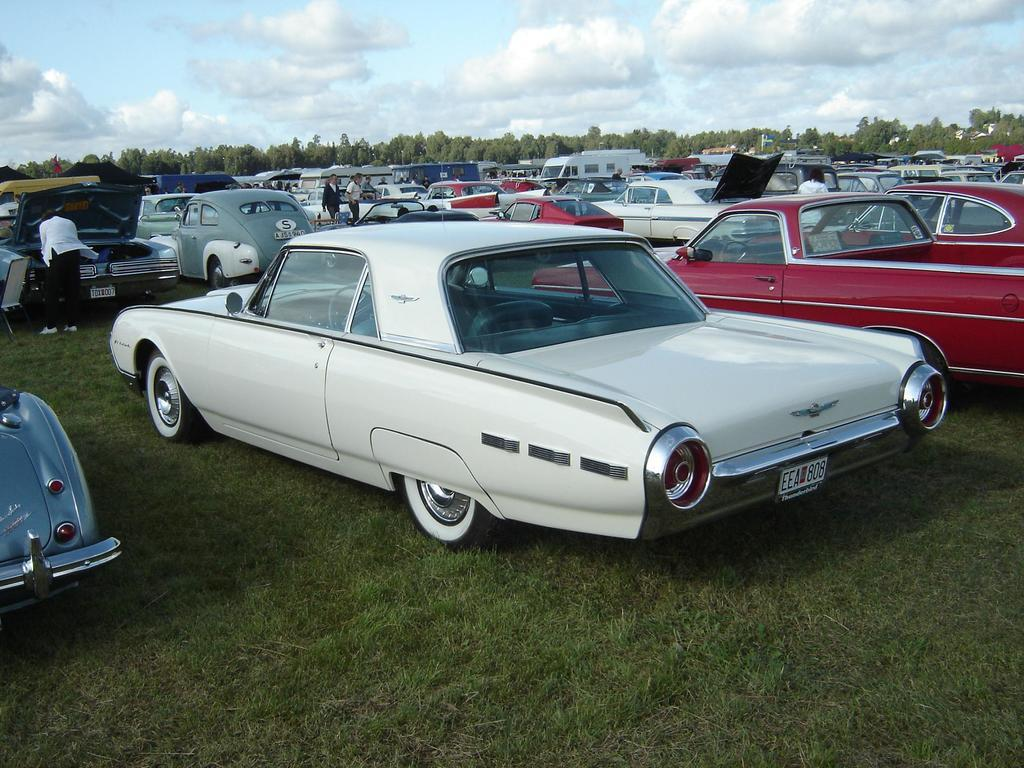What is the main subject of the image? The main subject of the image is a group of cars. What else can be seen in the image besides the cars? There are persons on the ground and trees in the background of the image. What is visible in the background of the image? The sky is visible in the background of the image, and clouds are present in the sky. What type of clam is being used as a decoration on the cars in the image? There are no clams present in the image, and they are not being used as decorations on the cars. 